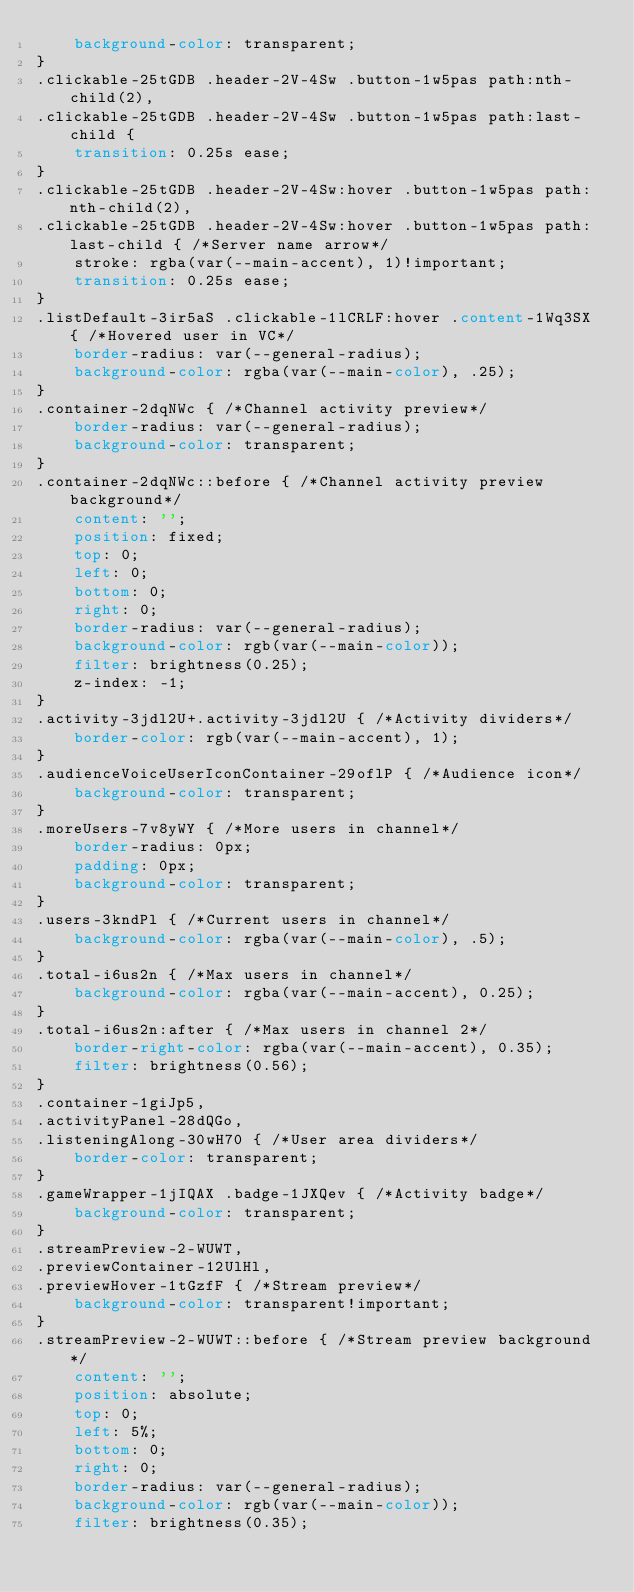<code> <loc_0><loc_0><loc_500><loc_500><_CSS_>    background-color: transparent;
}
.clickable-25tGDB .header-2V-4Sw .button-1w5pas path:nth-child(2),
.clickable-25tGDB .header-2V-4Sw .button-1w5pas path:last-child {
    transition: 0.25s ease;
}
.clickable-25tGDB .header-2V-4Sw:hover .button-1w5pas path:nth-child(2),
.clickable-25tGDB .header-2V-4Sw:hover .button-1w5pas path:last-child { /*Server name arrow*/
    stroke: rgba(var(--main-accent), 1)!important;
    transition: 0.25s ease;
}
.listDefault-3ir5aS .clickable-1lCRLF:hover .content-1Wq3SX { /*Hovered user in VC*/
    border-radius: var(--general-radius);
    background-color: rgba(var(--main-color), .25);
}
.container-2dqNWc { /*Channel activity preview*/
    border-radius: var(--general-radius);
    background-color: transparent;
}
.container-2dqNWc::before { /*Channel activity preview background*/
    content: '';
    position: fixed;
    top: 0;
    left: 0;
    bottom: 0;
    right: 0;
    border-radius: var(--general-radius);
    background-color: rgb(var(--main-color));
    filter: brightness(0.25);
    z-index: -1;
}
.activity-3jdl2U+.activity-3jdl2U { /*Activity dividers*/
    border-color: rgb(var(--main-accent), 1);
}
.audienceVoiceUserIconContainer-29oflP { /*Audience icon*/
    background-color: transparent;
}
.moreUsers-7v8yWY { /*More users in channel*/
    border-radius: 0px;
    padding: 0px;
    background-color: transparent;
}
.users-3kndPl { /*Current users in channel*/
    background-color: rgba(var(--main-color), .5);
}
.total-i6us2n { /*Max users in channel*/
    background-color: rgba(var(--main-accent), 0.25);
}
.total-i6us2n:after { /*Max users in channel 2*/
    border-right-color: rgba(var(--main-accent), 0.35);
    filter: brightness(0.56);
}
.container-1giJp5,
.activityPanel-28dQGo,
.listeningAlong-30wH70 { /*User area dividers*/
    border-color: transparent;
}
.gameWrapper-1jIQAX .badge-1JXQev { /*Activity badge*/
    background-color: transparent;
}
.streamPreview-2-WUWT,
.previewContainer-12UlHl,
.previewHover-1tGzfF { /*Stream preview*/
    background-color: transparent!important;
}
.streamPreview-2-WUWT::before { /*Stream preview background*/
    content: '';
    position: absolute;
    top: 0;
    left: 5%;
    bottom: 0;
    right: 0;
    border-radius: var(--general-radius);
    background-color: rgb(var(--main-color));
    filter: brightness(0.35);</code> 